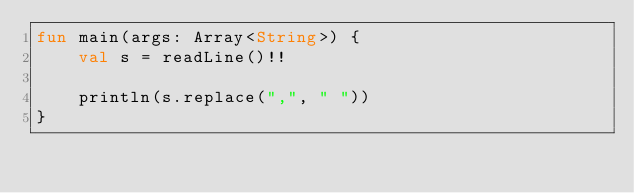Convert code to text. <code><loc_0><loc_0><loc_500><loc_500><_Kotlin_>fun main(args: Array<String>) {
    val s = readLine()!!

    println(s.replace(",", " "))
}</code> 